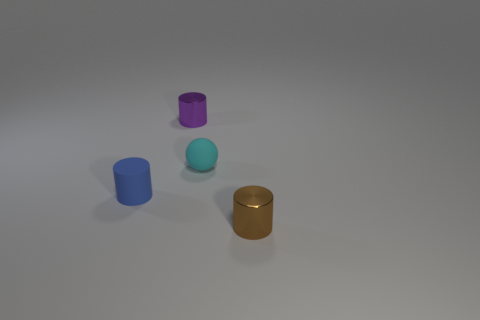Add 3 small blue objects. How many objects exist? 7 Subtract all spheres. How many objects are left? 3 Subtract all tiny cyan rubber objects. Subtract all matte things. How many objects are left? 1 Add 1 blue matte objects. How many blue matte objects are left? 2 Add 4 small shiny cylinders. How many small shiny cylinders exist? 6 Subtract 0 green cubes. How many objects are left? 4 